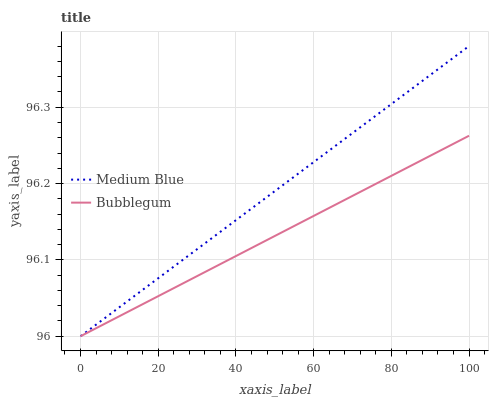Does Bubblegum have the maximum area under the curve?
Answer yes or no. No. Is Bubblegum the roughest?
Answer yes or no. No. Does Bubblegum have the highest value?
Answer yes or no. No. 